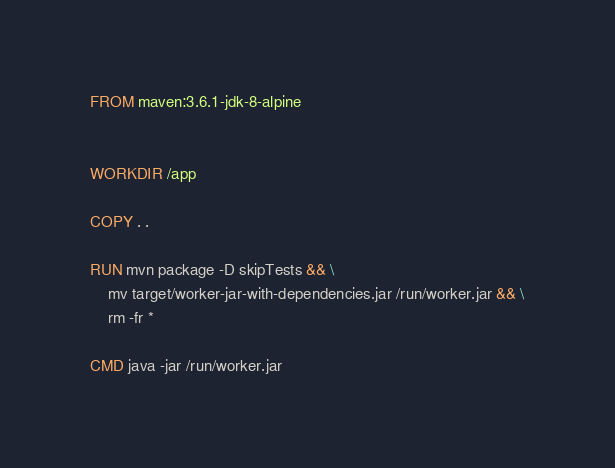<code> <loc_0><loc_0><loc_500><loc_500><_Dockerfile_>FROM maven:3.6.1-jdk-8-alpine


WORKDIR /app

COPY . .

RUN mvn package -D skipTests && \
    mv target/worker-jar-with-dependencies.jar /run/worker.jar && \
    rm -fr *

CMD java -jar /run/worker.jar</code> 